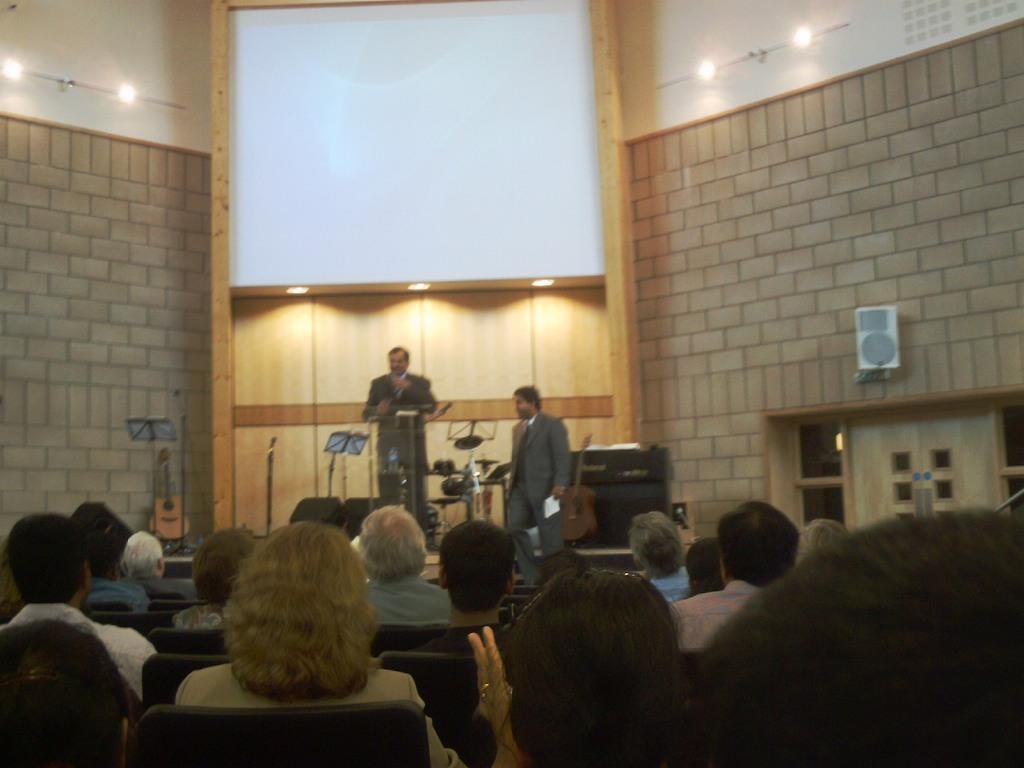In one or two sentences, can you explain what this image depicts? In this picture there are people those who are sitting on the chairs at the bottom side of the image and there is a man who is standing in the center of the image in front of a desk and a mic on the stage, there is another person beside him and there is a speaker on the wall on the right side of the image, there is a projector screen at the top side of the image and there are lamps in the image. 